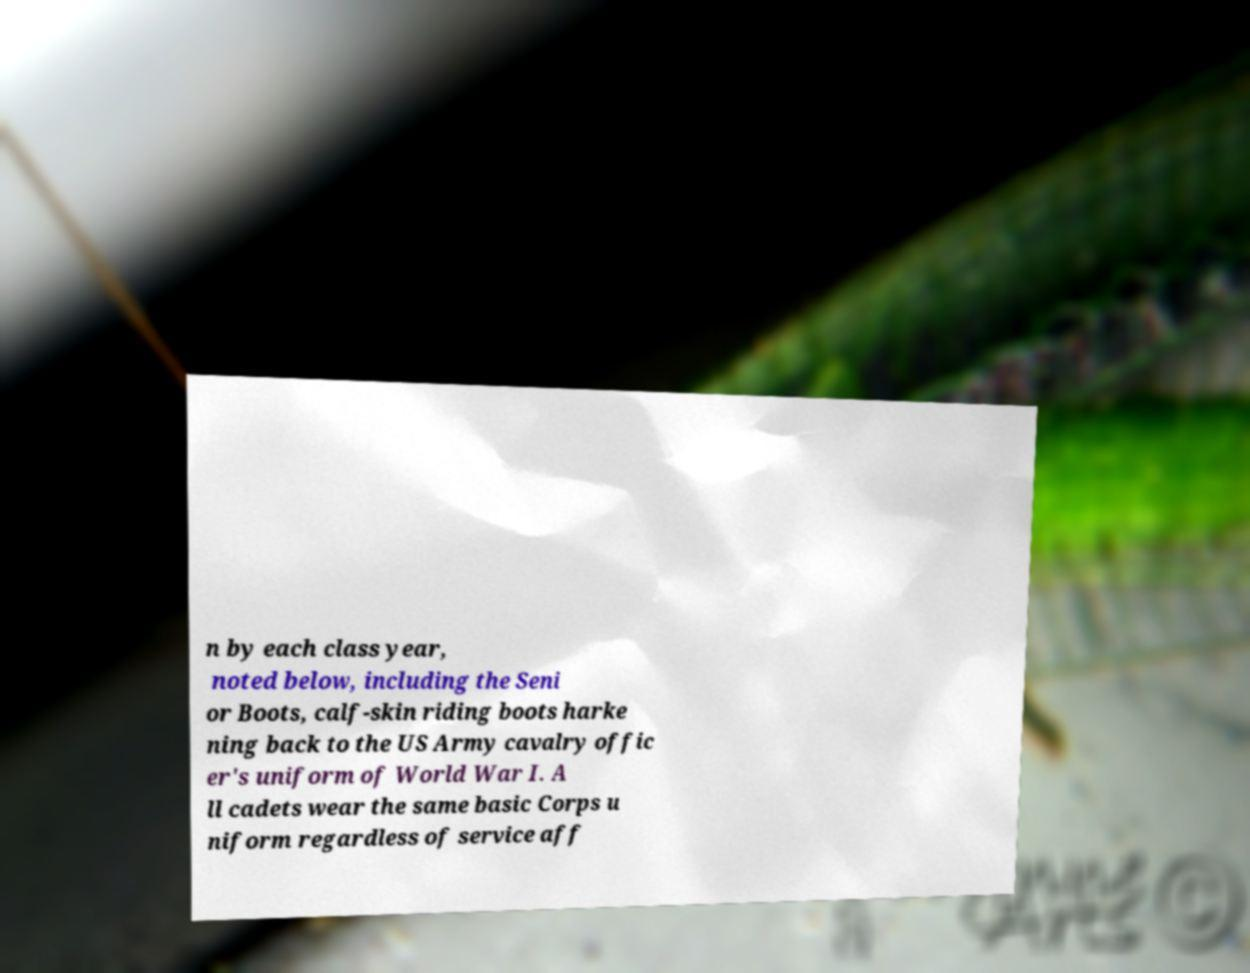I need the written content from this picture converted into text. Can you do that? n by each class year, noted below, including the Seni or Boots, calf-skin riding boots harke ning back to the US Army cavalry offic er's uniform of World War I. A ll cadets wear the same basic Corps u niform regardless of service aff 